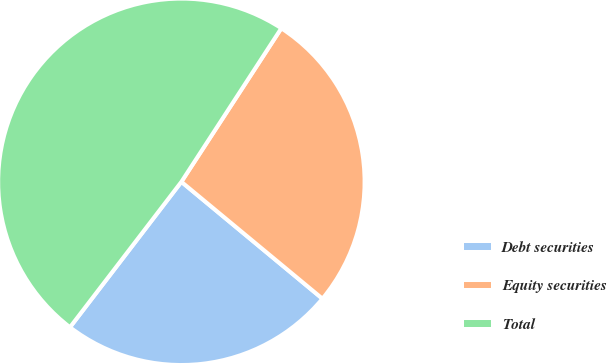Convert chart. <chart><loc_0><loc_0><loc_500><loc_500><pie_chart><fcel>Debt securities<fcel>Equity securities<fcel>Total<nl><fcel>24.39%<fcel>26.83%<fcel>48.78%<nl></chart> 